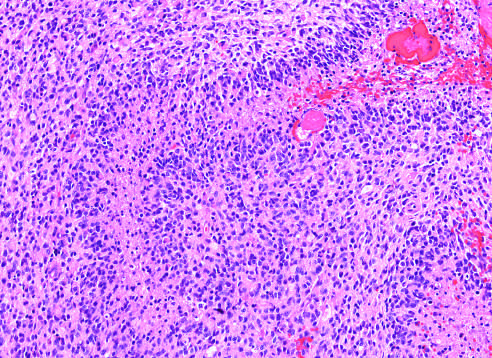what is a densely cellular tumor with necrosis and pseudo-palisading of tumor cell nuclei along the edge of the necrotic zone?
Answer the question using a single word or phrase. Glioblastoma 